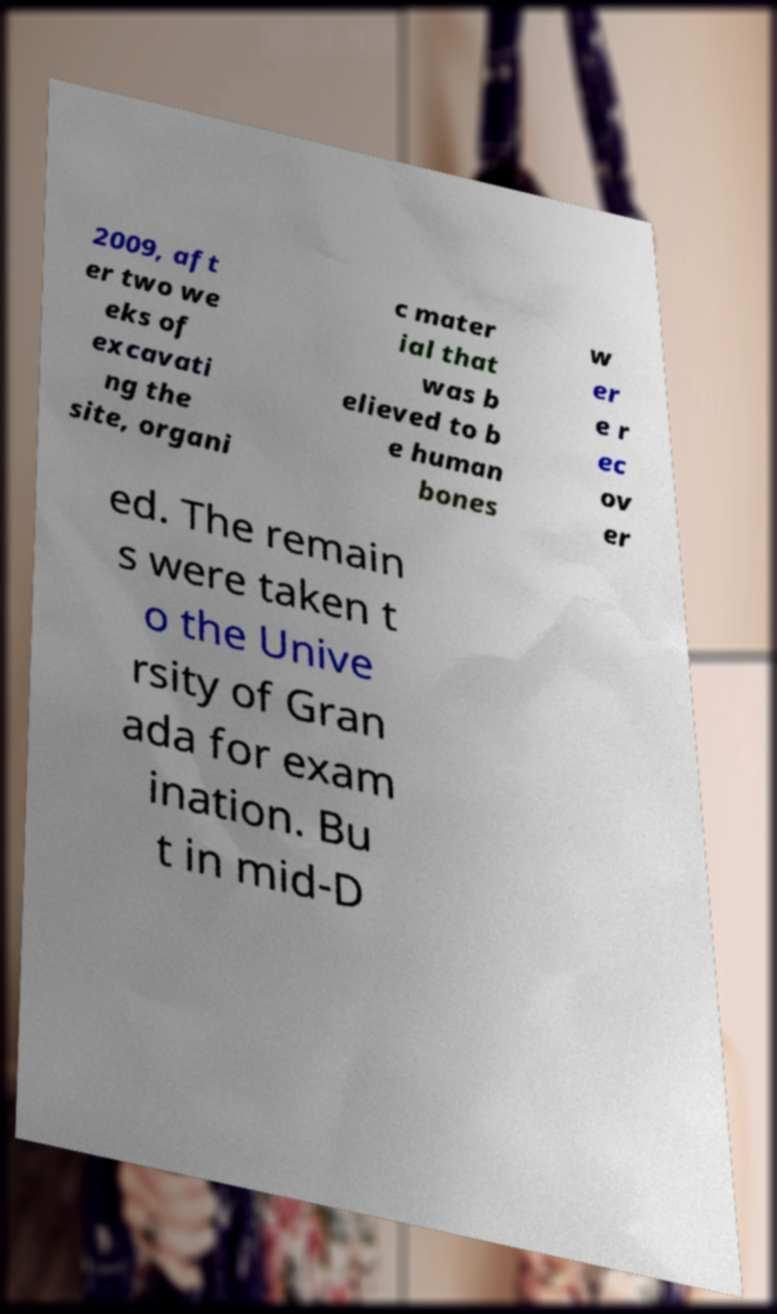What messages or text are displayed in this image? I need them in a readable, typed format. 2009, aft er two we eks of excavati ng the site, organi c mater ial that was b elieved to b e human bones w er e r ec ov er ed. The remain s were taken t o the Unive rsity of Gran ada for exam ination. Bu t in mid-D 